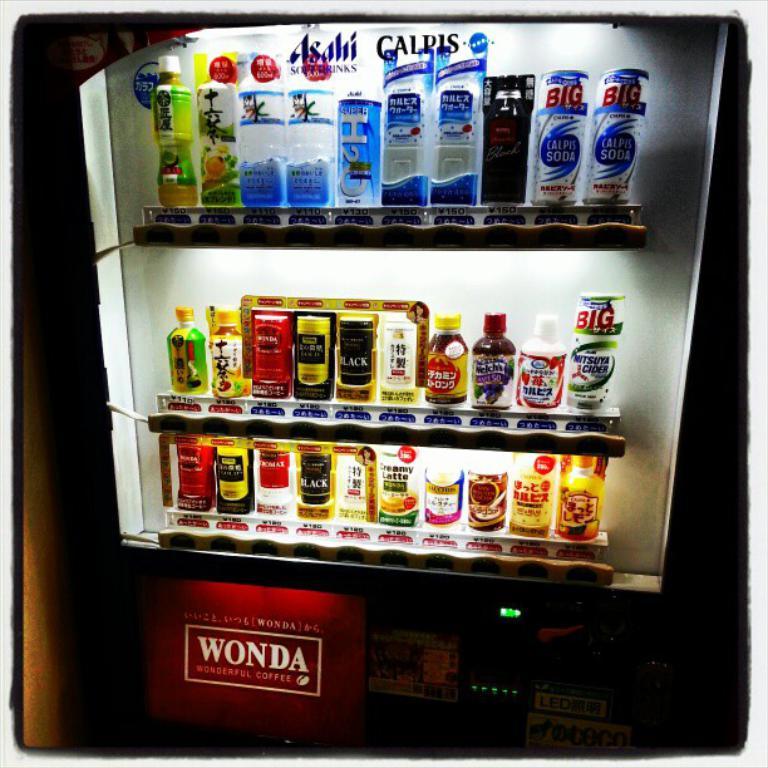What are the company names at the top of the machine?
Make the answer very short. Asahi, calpis. What does the red sign say?
Keep it short and to the point. Wonda. 